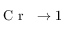<formula> <loc_0><loc_0><loc_500><loc_500>{ C r \to 1</formula> 